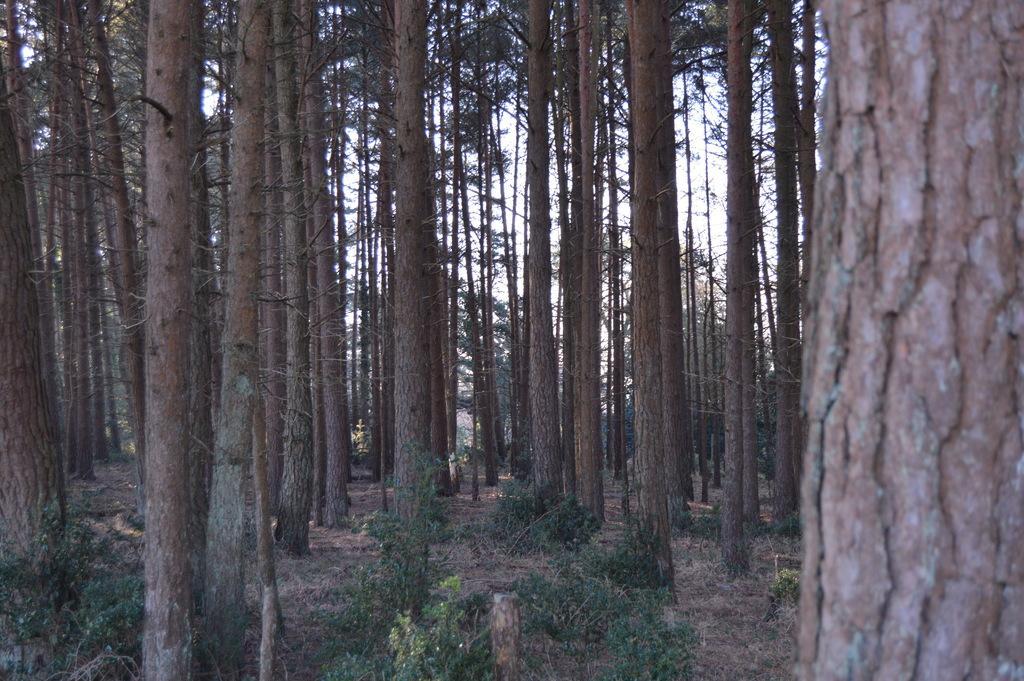In one or two sentences, can you explain what this image depicts? Here we can see plants and trees. In the background there is sky. 